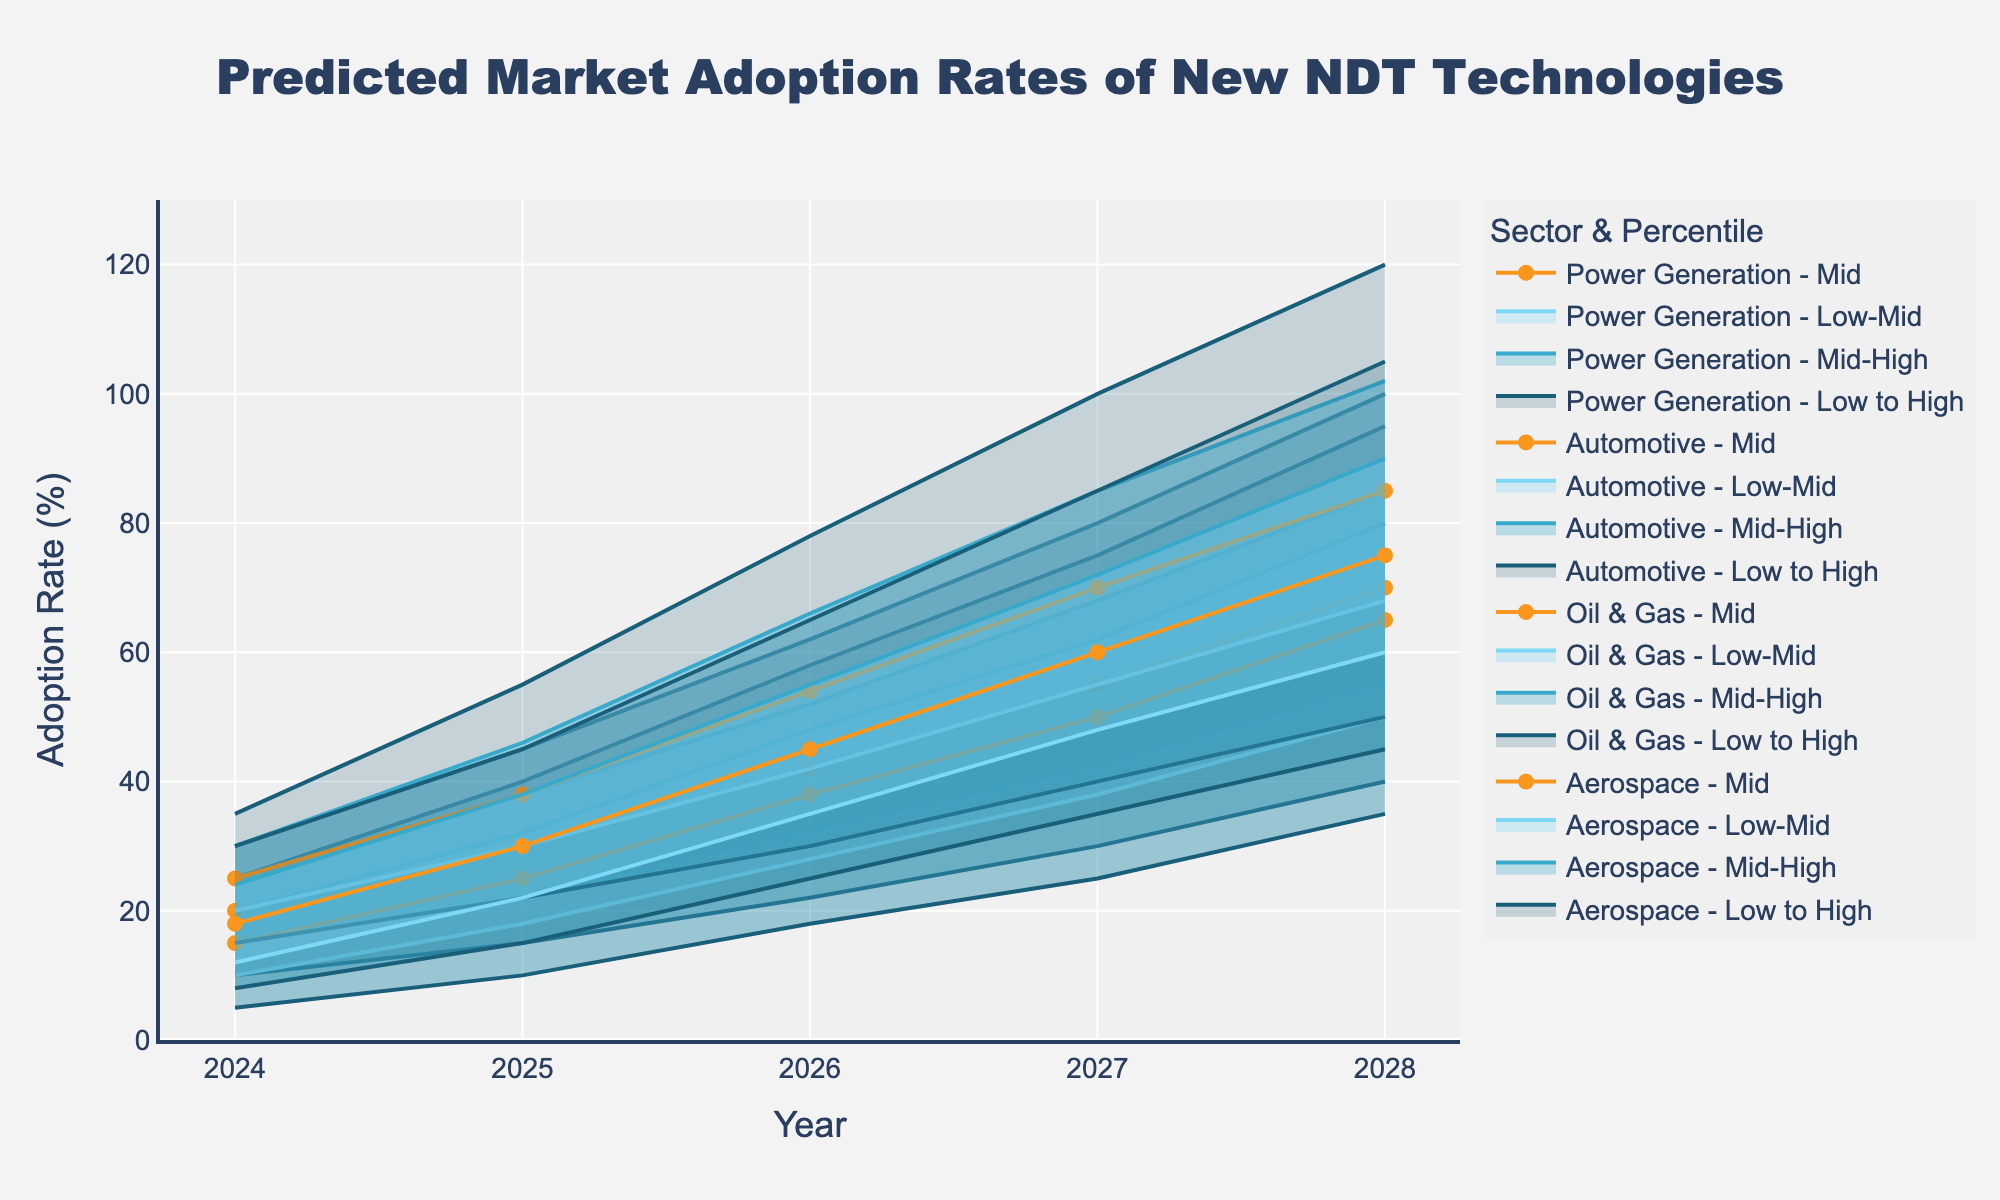How many sectors are represented in the fan chart? There are four distinct sectors plotted, evident from the legend which shows: Aerospace, Oil & Gas, Automotive, and Power Generation.
Answer: Four What is the adoption rate for Aerospace in the Mid category for the year 2027? Observing the Mid line for Aerospace in 2027, the value is 55%.
Answer: 55% Which sector shows the highest range (difference between High and Low) in 2028? For 2028, looking at the High and Low values: 
- Aerospace: 100% - 40% = 60%
- Oil & Gas: 95% - 35% = 60%
- Automotive: 120% - 50% = 70%
- Power Generation: 105% - 45% = 60%
The Automotive sector has the highest range of 70%.
Answer: Automotive What is the predicted adoption rate for the Mid-High projection for Oil & Gas in 2026? By examining the Mid-High line for Oil & Gas in 2026, the value is 48%.
Answer: 48% How does the Mid adoption rate for Automotive in 2025 compare to its Low adoption rate in the same year? In 2025, the Mid adoption rate for Automotive is 38%, and the Low adoption rate is 22%. Thus, the Mid rate is 38% - 22% = 16% higher than the Low rate.
Answer: 16% higher Which sector shows the steepest increase in the High adoption rate from 2024 to 2025? Comparing the High adoption rates:
- Aerospace: 45% - 30% = 15%
- Oil & Gas: 40% - 25% = 15%
- Automotive: 55% - 35% = 20%
- Power Generation: 45% - 30% = 15%
Automotive shows the steepest increase of 20%.
Answer: Automotive What is the trend for the Mid adoption rate in Power Generation from 2024 to 2028? Observing the Mid adoption rate values for Power Generation:
- 2024: 18%
- 2025: 30%
- 2026: 45%
- 2027: 60%
- 2028: 75%
There is a consistent increasing trend.
Answer: Increasing trend In which year does the Aerospace sector surpass a Mid adoption rate of 40%? Looking at the Mid adoption rate values for Aerospace:
- 2026: 42%
- 2025: 30%
Aerospace surpasses a Mid adoption rate of 40% in 2026.
Answer: 2026 What is the difference in the adoption rate between the Low-Mid and Mid-High projections for Automotive in 2025? For Automotive in 2025, the Low-Mid adoption is 30% and the Mid-High adoption is 46%. The difference is 46% - 30% = 16%.
Answer: 16% Which sector shows the smallest relative growth in the Mid adoption rate from 2024 to 2028? Relative growth in the Mid adoption rate:
- Aerospace: (70% - 20%) / 20% * 100% = 250%
- Oil & Gas: (65% - 15%) / 15% * 100% = 333.33%
- Automotive: (85% - 25%) / 25% * 100% = 240%
- Power Generation: (75% - 18%) / 18% * 100% = 316.67%
The sector with the smallest relative growth is Automotive, with 240%.
Answer: Automotive 